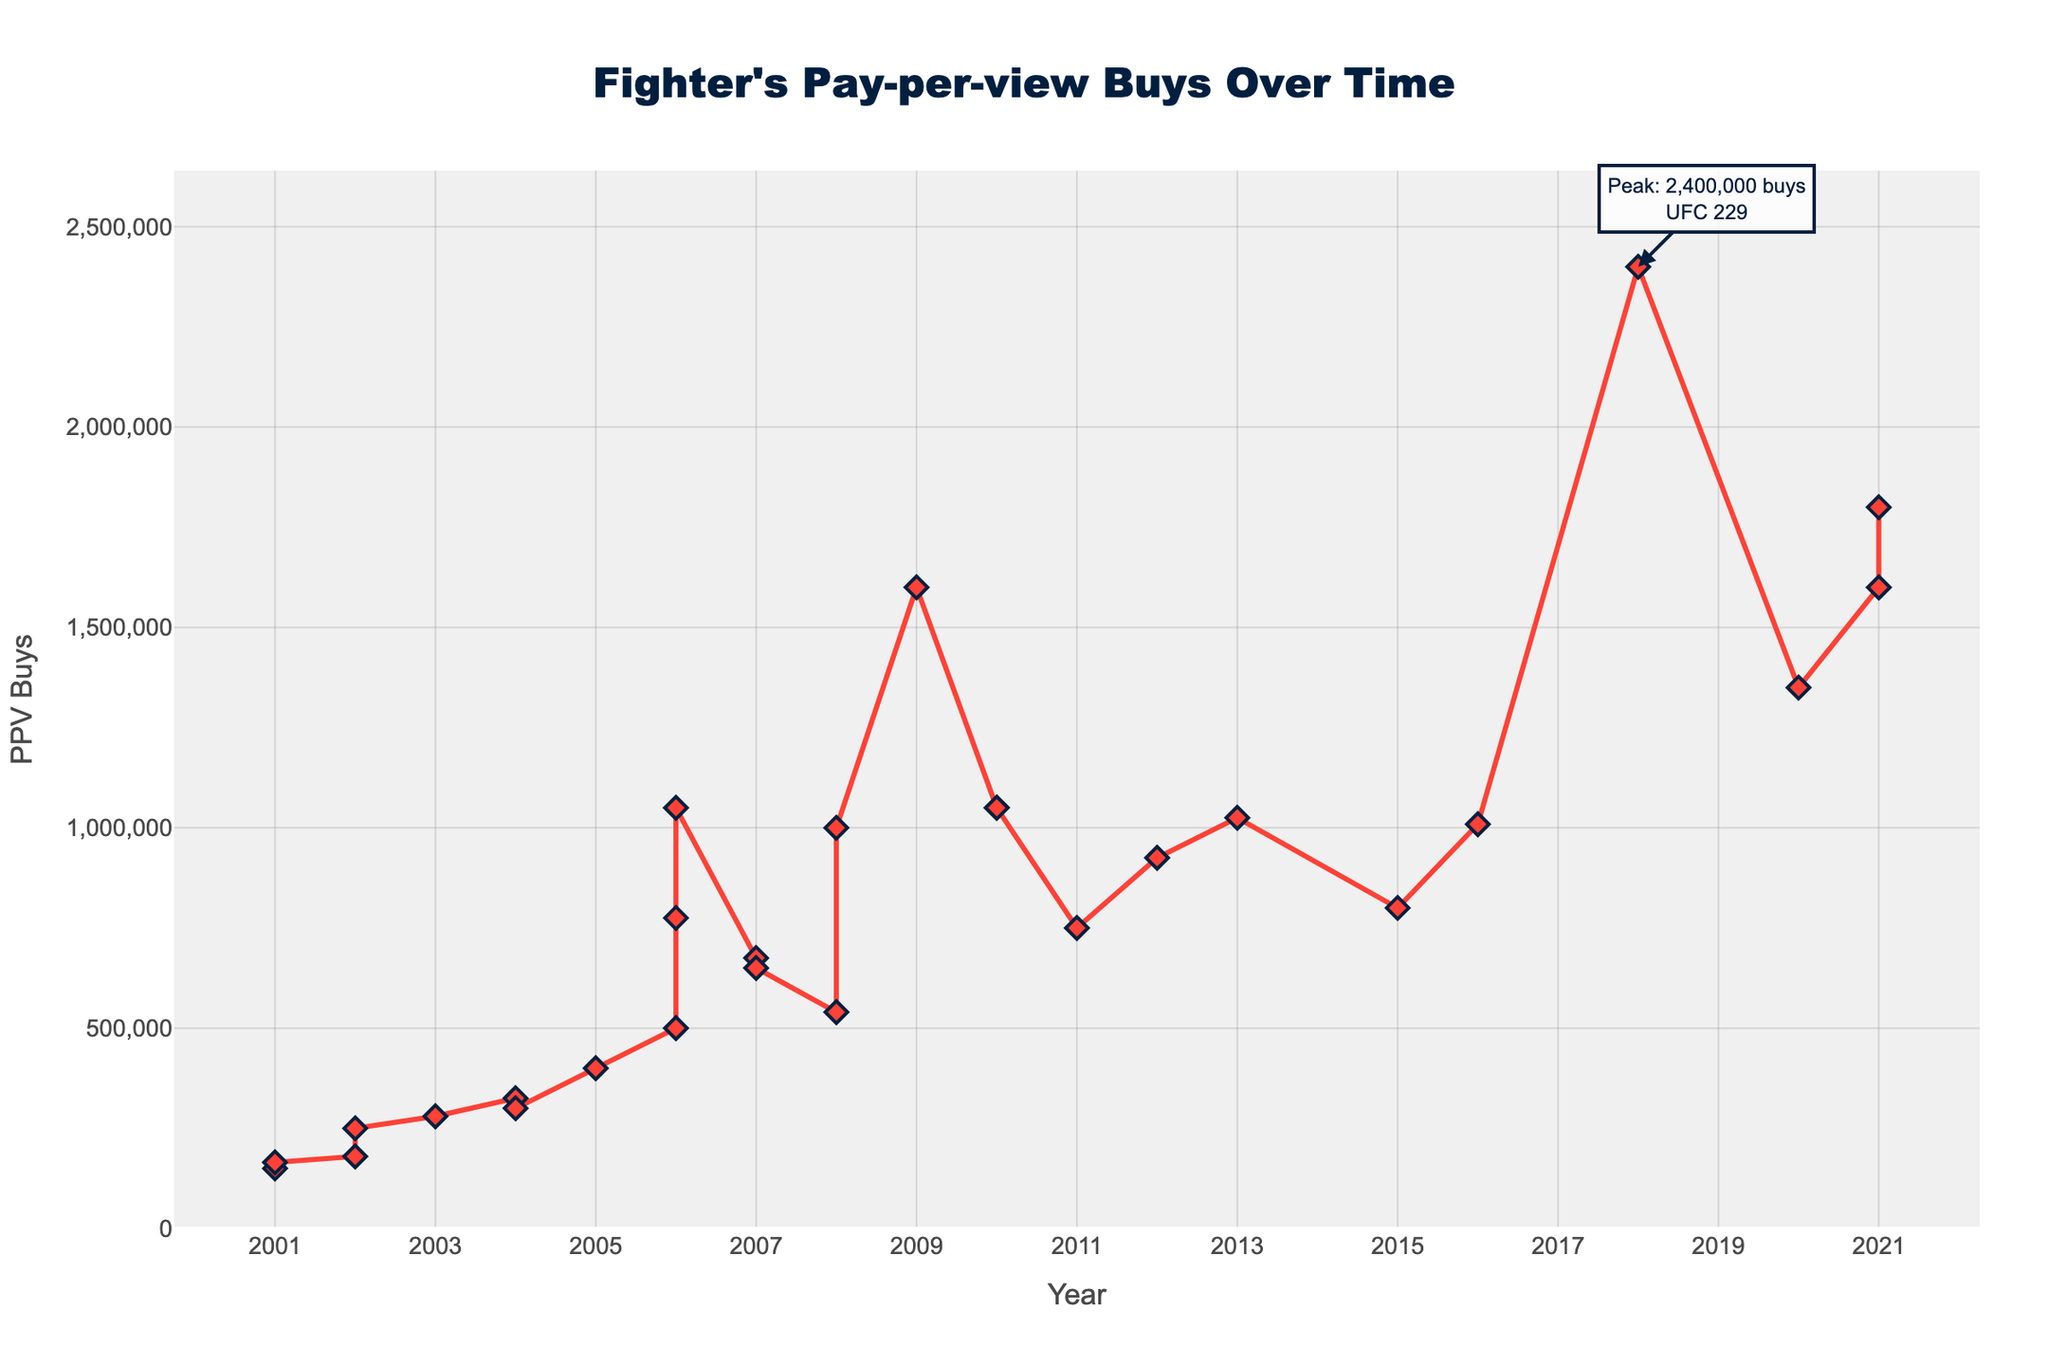Which event had the highest Pay-per-view buys? The annotation on the chart highlights the event with the highest PPV buys as UFC 229.
Answer: UFC 229 How many years saw more than 1,000,000 PPV buys? Observing the values on the y-axis and the peaks in the line chart, we see in the years 2006, 2008, 2009, 2010, 2013, 2016, 2018, 2020, and 2021, UFC events exceeded 1,000,000 PPV buys.
Answer: 9 What was the trend in PPV buys from UFC 31 to UFC 40? The line chart shows a steady increase from UFC 31 with 150,000 PPV buys to UFC 40 with 250,000 PPV buys.
Answer: Increasing How did the PPV buys for UFC 100 compare to UFC 66? UFC 100 had 1,600,000 PPV buys while UFC 66 had 1,050,000 PPV buys, indicating a higher interest in UFC 100.
Answer: UFC 100 had higher PPV buys In which year did the PPV buys exceed the 1,000,000 mark for the first time? By checking the data points and the y-axis, it is clear that the PPV buys first exceeded 1,000,000 in 2006 at UFC 66.
Answer: 2006 Which event had the lowest Pay-per-view buys, and how many buys were there? Referring to the lowest point on the line chart, UFC 31 had the lowest PPV buys with 150,000.
Answer: UFC 31, 150,000 buys What was the approximate average number of PPV buys from 2001 to 2006? To approximate, first sum the PPV buys from 2001 (150,000 + 165,000) to 2006 (500,000 + 775,000 + 1,050,000). Total is 2,820,000 divided by 6 events gives 470,000.
Answer: 470,000 Which year saw the largest single-year increase in PPV buys? Observing the largest vertical gap between two consecutive points on the line chart, the greatest increase was from 2008 (UFC 92) to 2009 (UFC 100). PPV buys increased by 600,000.
Answer: 2009 How does the PPV buys trend from 2016 to 2018 compare to 2018 to 2021? From 2016 to 2018, the trend shows a steep increase. From 2018 to 2021, it shows high fluctuation with large numbers but not a continuous increase.
Answer: More consistent increase from 2016 to 2018 